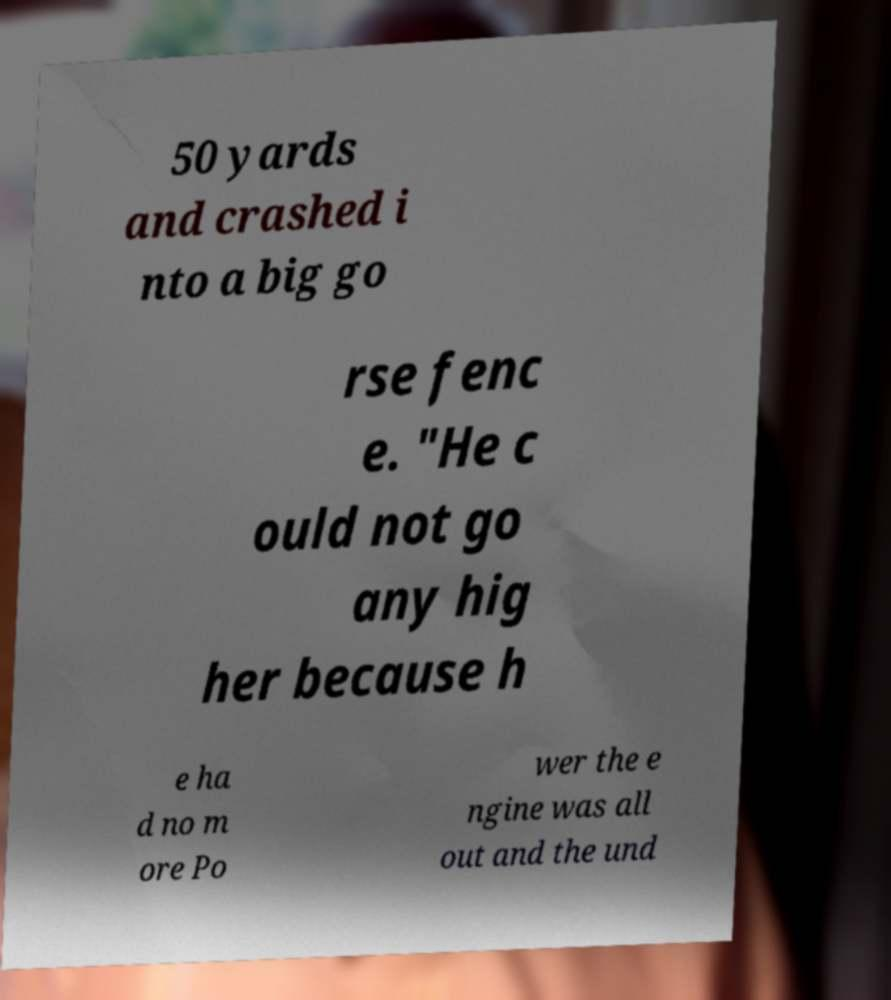Can you accurately transcribe the text from the provided image for me? 50 yards and crashed i nto a big go rse fenc e. "He c ould not go any hig her because h e ha d no m ore Po wer the e ngine was all out and the und 